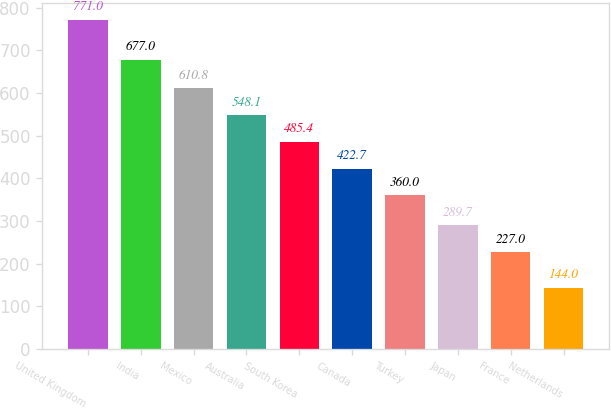<chart> <loc_0><loc_0><loc_500><loc_500><bar_chart><fcel>United Kingdom<fcel>India<fcel>Mexico<fcel>Australia<fcel>South Korea<fcel>Canada<fcel>Turkey<fcel>Japan<fcel>France<fcel>Netherlands<nl><fcel>771<fcel>677<fcel>610.8<fcel>548.1<fcel>485.4<fcel>422.7<fcel>360<fcel>289.7<fcel>227<fcel>144<nl></chart> 